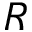Convert formula to latex. <formula><loc_0><loc_0><loc_500><loc_500>R</formula> 